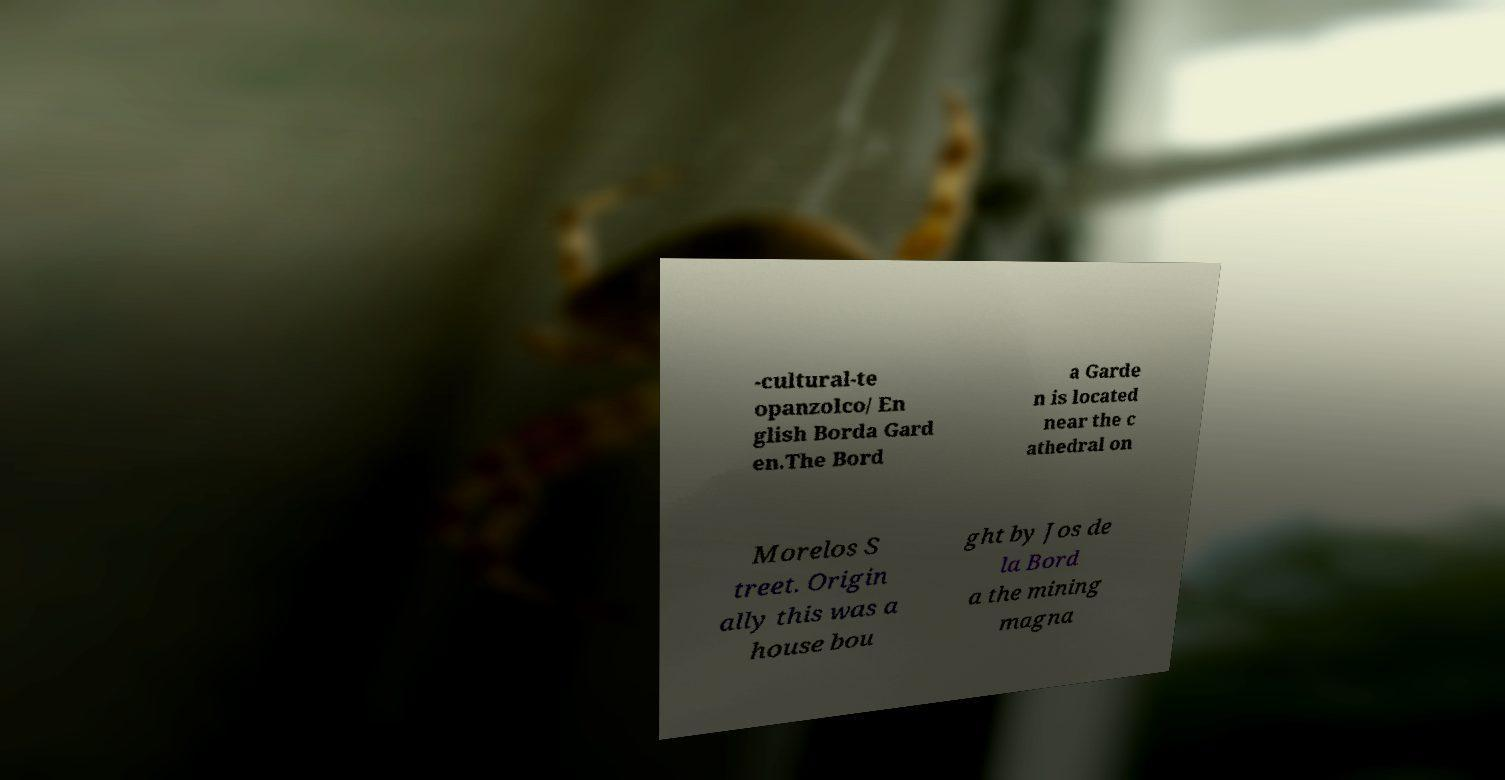Can you read and provide the text displayed in the image?This photo seems to have some interesting text. Can you extract and type it out for me? -cultural-te opanzolco/ En glish Borda Gard en.The Bord a Garde n is located near the c athedral on Morelos S treet. Origin ally this was a house bou ght by Jos de la Bord a the mining magna 